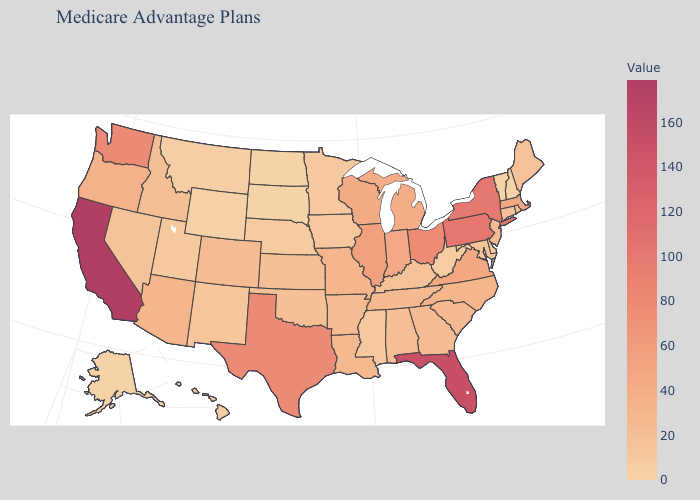Does the map have missing data?
Give a very brief answer. No. Which states have the highest value in the USA?
Short answer required. California. Among the states that border Vermont , which have the highest value?
Be succinct. New York. Among the states that border Minnesota , does Wisconsin have the highest value?
Quick response, please. Yes. Which states have the lowest value in the Northeast?
Concise answer only. New Hampshire, Vermont. Which states hav the highest value in the MidWest?
Concise answer only. Ohio. 